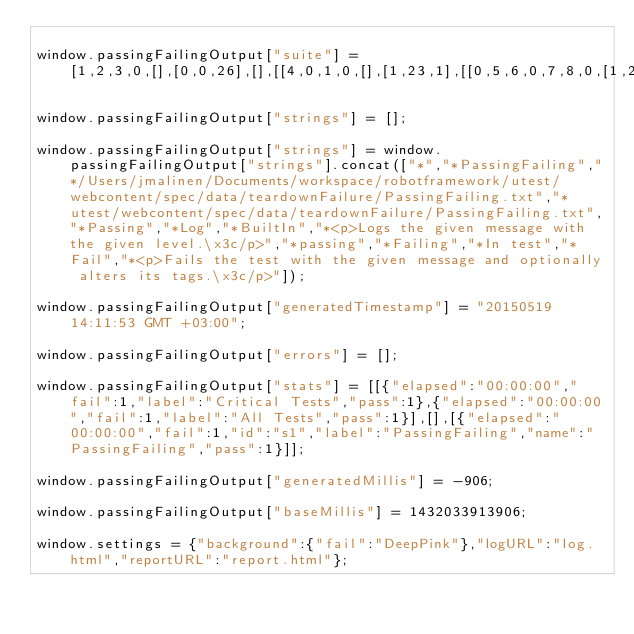<code> <loc_0><loc_0><loc_500><loc_500><_JavaScript_>
window.passingFailingOutput["suite"] = [1,2,3,0,[],[0,0,26],[],[[4,0,1,0,[],[1,23,1],[[0,5,6,0,7,8,0,[1,24,0],[],[[24,2,8]]]]],[9,0,1,0,[],[0,25,1,10],[[0,11,6,0,12,10,0,[0,25,1],[],[[26,4,10]]]]]],[],[2,1,2,1]];

window.passingFailingOutput["strings"] = [];

window.passingFailingOutput["strings"] = window.passingFailingOutput["strings"].concat(["*","*PassingFailing","*/Users/jmalinen/Documents/workspace/robotframework/utest/webcontent/spec/data/teardownFailure/PassingFailing.txt","*utest/webcontent/spec/data/teardownFailure/PassingFailing.txt","*Passing","*Log","*BuiltIn","*<p>Logs the given message with the given level.\x3c/p>","*passing","*Failing","*In test","*Fail","*<p>Fails the test with the given message and optionally alters its tags.\x3c/p>"]);

window.passingFailingOutput["generatedTimestamp"] = "20150519 14:11:53 GMT +03:00";

window.passingFailingOutput["errors"] = [];

window.passingFailingOutput["stats"] = [[{"elapsed":"00:00:00","fail":1,"label":"Critical Tests","pass":1},{"elapsed":"00:00:00","fail":1,"label":"All Tests","pass":1}],[],[{"elapsed":"00:00:00","fail":1,"id":"s1","label":"PassingFailing","name":"PassingFailing","pass":1}]];

window.passingFailingOutput["generatedMillis"] = -906;

window.passingFailingOutput["baseMillis"] = 1432033913906;

window.settings = {"background":{"fail":"DeepPink"},"logURL":"log.html","reportURL":"report.html"};

</code> 